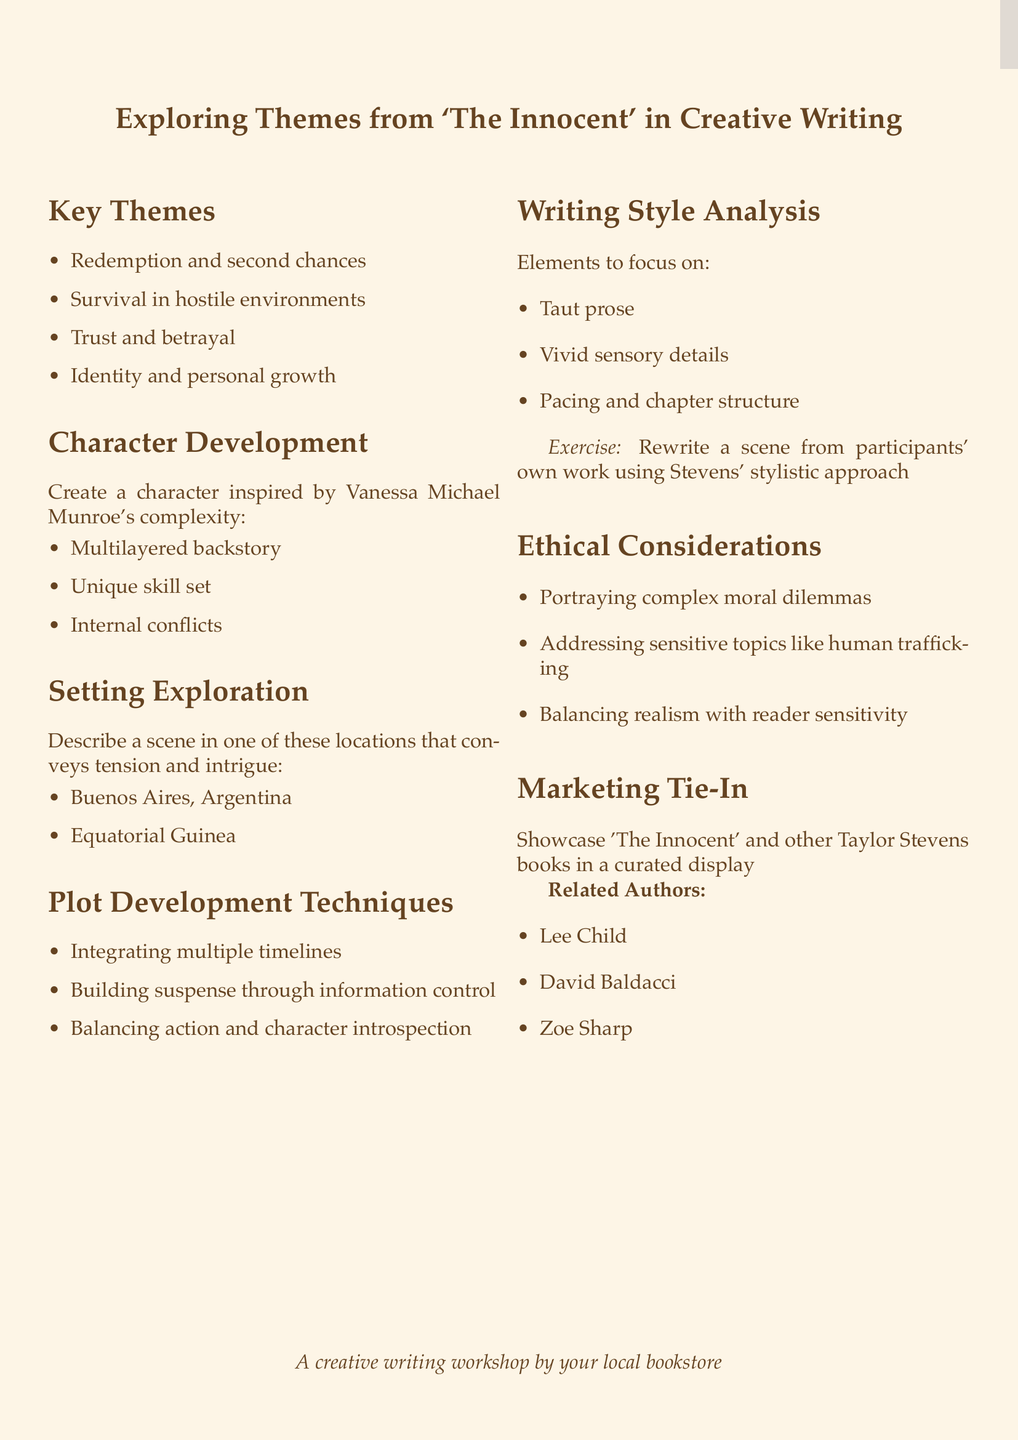What is the workshop title? The title of the workshop is specified in the document's heading.
Answer: Exploring Themes from 'The Innocent' in Creative Writing How many key themes are listed? The number of key themes can be counted in the list provided under the key themes section.
Answer: 4 What exercise is mentioned for character development? The document specifies an exercise related to character development.
Answer: Create a character inspired by Vanessa Michael Munroe's complexity Which two locations are highlighted for setting exploration? The document includes a list of locations in the setting exploration section.
Answer: Buenos Aires, Argentina and Equatorial Guinea What writing style element focuses on chapter structure? The specific element of writing style that is mentioned related to chapter structure can be found in the analysis section.
Answer: Pacing and chapter structure Name one ethical consideration outlined in the document. The document lists ethical considerations that should be addressed during the workshop.
Answer: Portraying complex moral dilemmas Which authors are suggested for the marketing tie-in? The related authors for the marketing tie-in are listed towards the end of the document.
Answer: Lee Child, David Baldacci, Zoe Sharp 